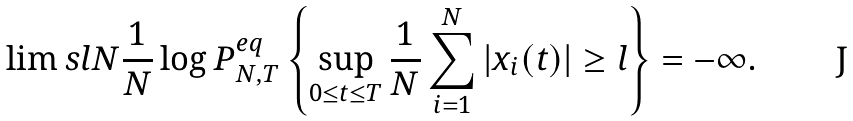Convert formula to latex. <formula><loc_0><loc_0><loc_500><loc_500>\lim s l N \frac { 1 } { N } \log P _ { N , T } ^ { e q } \left \{ \sup _ { 0 \leq t \leq T } \frac { 1 } { N } \sum _ { i = 1 } ^ { N } | x _ { i } ( t ) | \geq l \right \} = - \infty .</formula> 